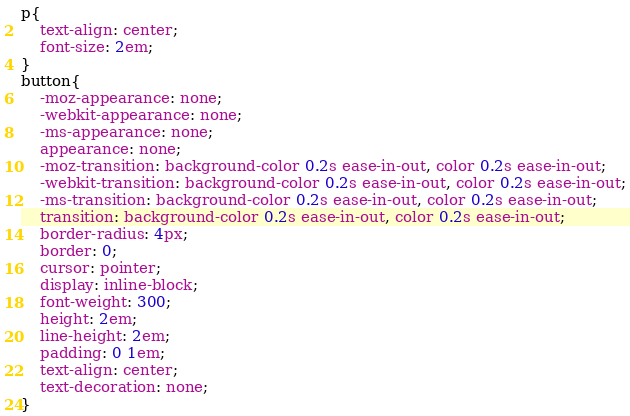Convert code to text. <code><loc_0><loc_0><loc_500><loc_500><_CSS_>p{
    text-align: center;
    font-size: 2em;
}
button{
    -moz-appearance: none;
    -webkit-appearance: none;
    -ms-appearance: none;
    appearance: none;
    -moz-transition: background-color 0.2s ease-in-out, color 0.2s ease-in-out;
    -webkit-transition: background-color 0.2s ease-in-out, color 0.2s ease-in-out;
    -ms-transition: background-color 0.2s ease-in-out, color 0.2s ease-in-out;
    transition: background-color 0.2s ease-in-out, color 0.2s ease-in-out;
    border-radius: 4px;
    border: 0;
    cursor: pointer;
    display: inline-block;
    font-weight: 300;
    height: 2em;
    line-height: 2em;
    padding: 0 1em;
    text-align: center;
    text-decoration: none;
}</code> 